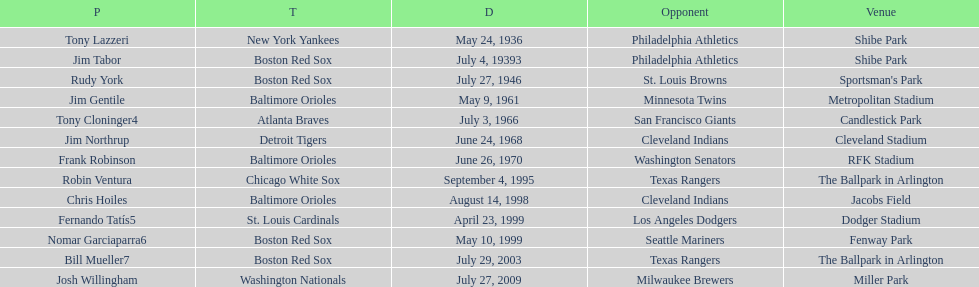What is the name of the most recent individual who has achieved this to date? Josh Willingham. 